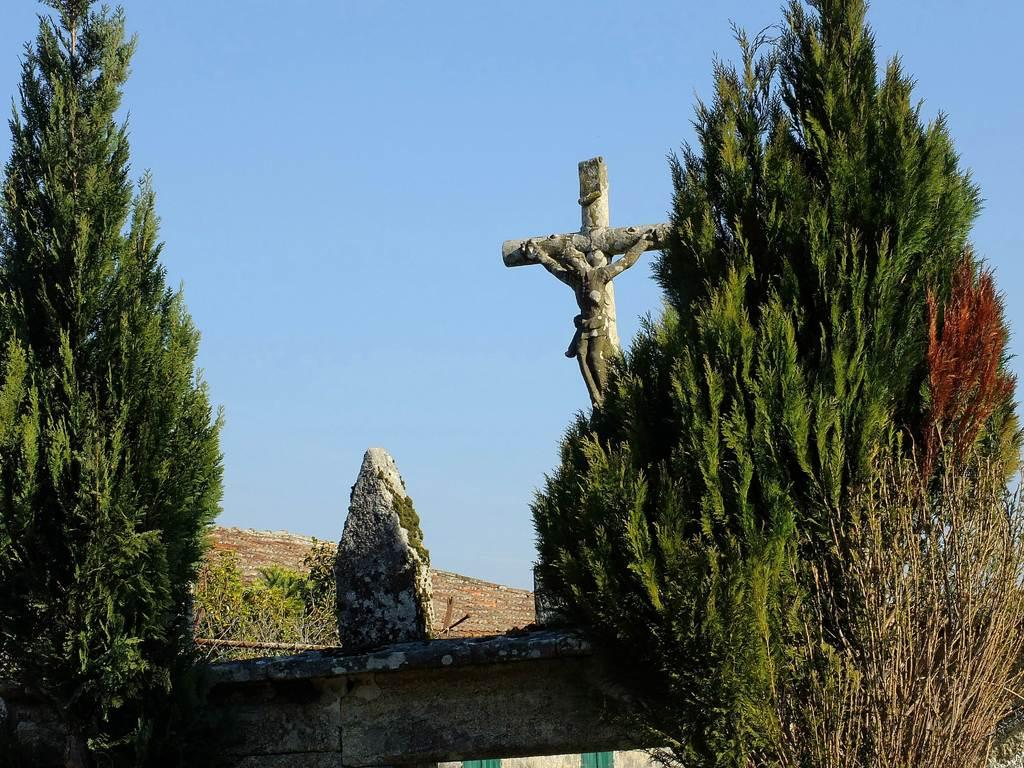What type of natural elements can be seen in the image? There are trees in the image. What man-made object is present in the image? There is a statue in the image. What is the color of the sky in the image? The sky is blue in color. Can you tell me how the fog affects the visibility of the statue in the image? There is no fog present in the image, so its effect on the visibility of the statue cannot be determined. What role does the governor play in the image? There is no governor present in the image, so it is not possible to determine any role they might play. 